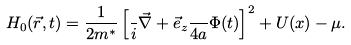<formula> <loc_0><loc_0><loc_500><loc_500>H _ { 0 } ( \vec { r } , t ) = \frac { 1 } { 2 m ^ { * } } \left [ \frac { } { i } \vec { \nabla } + \vec { e } _ { z } \frac { } { 4 a } \Phi ( t ) \right ] ^ { 2 } + U ( x ) - \mu .</formula> 